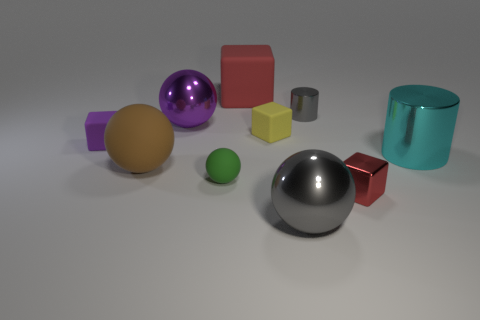There is a yellow thing; what number of small blocks are in front of it?
Provide a succinct answer. 2. Are any big red cubes visible?
Make the answer very short. Yes. How big is the metallic cylinder that is on the right side of the small object that is behind the metal sphere that is to the left of the green rubber thing?
Your answer should be compact. Large. How many other things are the same size as the purple matte thing?
Provide a succinct answer. 4. What is the size of the red thing that is in front of the purple metallic ball?
Your answer should be compact. Small. Is there any other thing of the same color as the small cylinder?
Your response must be concise. Yes. Do the small block that is to the right of the tiny gray thing and the cyan object have the same material?
Provide a short and direct response. Yes. What number of things are behind the red shiny block and left of the cyan metallic cylinder?
Keep it short and to the point. 7. There is a matte ball on the right side of the shiny ball that is behind the red metallic object; how big is it?
Offer a terse response. Small. Is there any other thing that is the same material as the gray sphere?
Offer a terse response. Yes. 